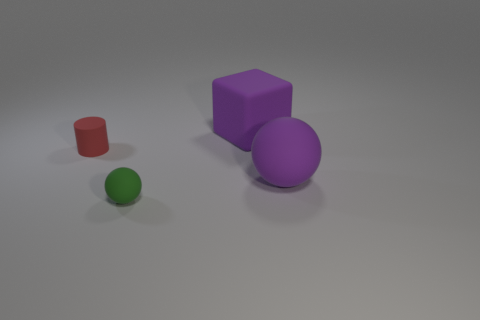Add 2 purple blocks. How many objects exist? 6 Subtract all blocks. How many objects are left? 3 Subtract all small brown shiny objects. Subtract all small rubber spheres. How many objects are left? 3 Add 2 green things. How many green things are left? 3 Add 3 big green things. How many big green things exist? 3 Subtract 1 purple spheres. How many objects are left? 3 